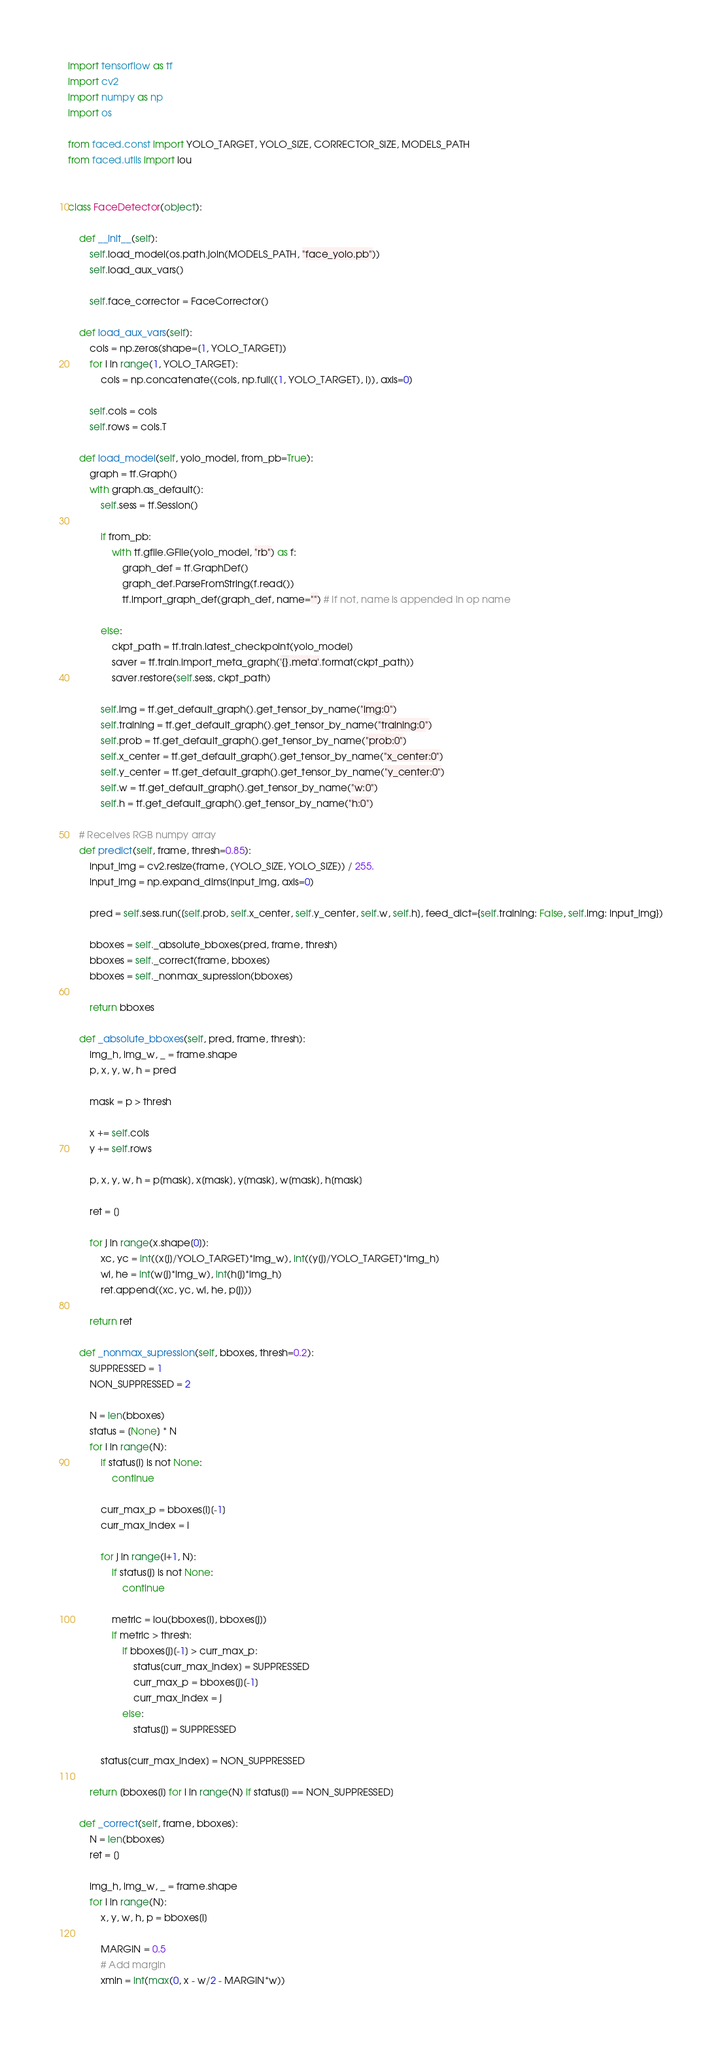Convert code to text. <code><loc_0><loc_0><loc_500><loc_500><_Python_>import tensorflow as tf
import cv2
import numpy as np
import os

from faced.const import YOLO_TARGET, YOLO_SIZE, CORRECTOR_SIZE, MODELS_PATH
from faced.utils import iou


class FaceDetector(object):

    def __init__(self):
        self.load_model(os.path.join(MODELS_PATH, "face_yolo.pb"))
        self.load_aux_vars()

        self.face_corrector = FaceCorrector()

    def load_aux_vars(self):
        cols = np.zeros(shape=[1, YOLO_TARGET])
        for i in range(1, YOLO_TARGET):
            cols = np.concatenate((cols, np.full((1, YOLO_TARGET), i)), axis=0)

        self.cols = cols
        self.rows = cols.T

    def load_model(self, yolo_model, from_pb=True):
        graph = tf.Graph()
        with graph.as_default():
            self.sess = tf.Session()

            if from_pb:
                with tf.gfile.GFile(yolo_model, "rb") as f:
                    graph_def = tf.GraphDef()
                    graph_def.ParseFromString(f.read())
                    tf.import_graph_def(graph_def, name="") # If not, name is appended in op name

            else:
                ckpt_path = tf.train.latest_checkpoint(yolo_model)
                saver = tf.train.import_meta_graph('{}.meta'.format(ckpt_path))
                saver.restore(self.sess, ckpt_path)

            self.img = tf.get_default_graph().get_tensor_by_name("img:0")
            self.training = tf.get_default_graph().get_tensor_by_name("training:0")
            self.prob = tf.get_default_graph().get_tensor_by_name("prob:0")
            self.x_center = tf.get_default_graph().get_tensor_by_name("x_center:0")
            self.y_center = tf.get_default_graph().get_tensor_by_name("y_center:0")
            self.w = tf.get_default_graph().get_tensor_by_name("w:0")
            self.h = tf.get_default_graph().get_tensor_by_name("h:0")

    # Receives RGB numpy array
    def predict(self, frame, thresh=0.85):
        input_img = cv2.resize(frame, (YOLO_SIZE, YOLO_SIZE)) / 255.
        input_img = np.expand_dims(input_img, axis=0)

        pred = self.sess.run([self.prob, self.x_center, self.y_center, self.w, self.h], feed_dict={self.training: False, self.img: input_img})

        bboxes = self._absolute_bboxes(pred, frame, thresh)
        bboxes = self._correct(frame, bboxes)
        bboxes = self._nonmax_supression(bboxes)

        return bboxes

    def _absolute_bboxes(self, pred, frame, thresh):
        img_h, img_w, _ = frame.shape
        p, x, y, w, h = pred

        mask = p > thresh

        x += self.cols
        y += self.rows

        p, x, y, w, h = p[mask], x[mask], y[mask], w[mask], h[mask]

        ret = []

        for j in range(x.shape[0]):
            xc, yc = int((x[j]/YOLO_TARGET)*img_w), int((y[j]/YOLO_TARGET)*img_h)
            wi, he = int(w[j]*img_w), int(h[j]*img_h)
            ret.append((xc, yc, wi, he, p[j]))

        return ret

    def _nonmax_supression(self, bboxes, thresh=0.2):
        SUPPRESSED = 1
        NON_SUPPRESSED = 2

        N = len(bboxes)
        status = [None] * N
        for i in range(N):
            if status[i] is not None:
                continue

            curr_max_p = bboxes[i][-1]
            curr_max_index = i

            for j in range(i+1, N):
                if status[j] is not None:
                    continue

                metric = iou(bboxes[i], bboxes[j])
                if metric > thresh:
                    if bboxes[j][-1] > curr_max_p:
                        status[curr_max_index] = SUPPRESSED
                        curr_max_p = bboxes[j][-1]
                        curr_max_index = j
                    else:
                        status[j] = SUPPRESSED

            status[curr_max_index] = NON_SUPPRESSED

        return [bboxes[i] for i in range(N) if status[i] == NON_SUPPRESSED]

    def _correct(self, frame, bboxes):
        N = len(bboxes)
        ret = []

        img_h, img_w, _ = frame.shape
        for i in range(N):
            x, y, w, h, p = bboxes[i]

            MARGIN = 0.5
            # Add margin
            xmin = int(max(0, x - w/2 - MARGIN*w))</code> 